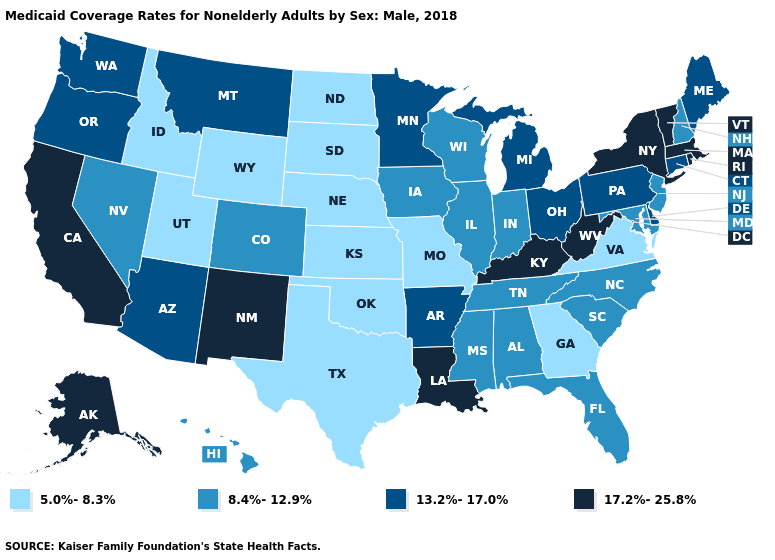Does Oklahoma have the same value as New Hampshire?
Concise answer only. No. What is the lowest value in states that border Wisconsin?
Keep it brief. 8.4%-12.9%. What is the lowest value in the Northeast?
Answer briefly. 8.4%-12.9%. What is the highest value in the USA?
Answer briefly. 17.2%-25.8%. Does the map have missing data?
Concise answer only. No. Is the legend a continuous bar?
Give a very brief answer. No. Name the states that have a value in the range 13.2%-17.0%?
Answer briefly. Arizona, Arkansas, Connecticut, Delaware, Maine, Michigan, Minnesota, Montana, Ohio, Oregon, Pennsylvania, Washington. What is the value of Oklahoma?
Answer briefly. 5.0%-8.3%. Which states have the lowest value in the South?
Write a very short answer. Georgia, Oklahoma, Texas, Virginia. What is the value of Louisiana?
Short answer required. 17.2%-25.8%. Does Wyoming have the lowest value in the USA?
Answer briefly. Yes. Does Wyoming have the lowest value in the West?
Be succinct. Yes. What is the value of Michigan?
Be succinct. 13.2%-17.0%. Which states have the lowest value in the USA?
Quick response, please. Georgia, Idaho, Kansas, Missouri, Nebraska, North Dakota, Oklahoma, South Dakota, Texas, Utah, Virginia, Wyoming. Name the states that have a value in the range 13.2%-17.0%?
Write a very short answer. Arizona, Arkansas, Connecticut, Delaware, Maine, Michigan, Minnesota, Montana, Ohio, Oregon, Pennsylvania, Washington. 